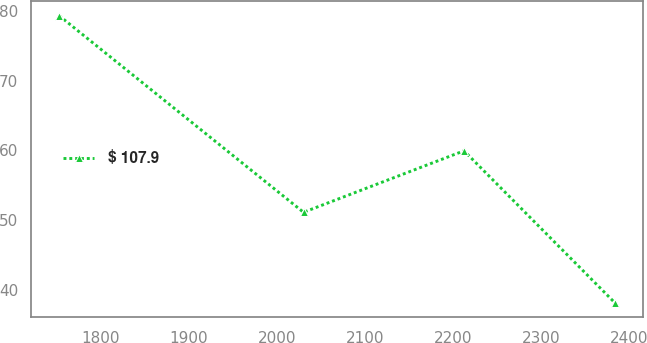<chart> <loc_0><loc_0><loc_500><loc_500><line_chart><ecel><fcel>$ 107.9<nl><fcel>1752.79<fcel>79.35<nl><fcel>2030.22<fcel>51.11<nl><fcel>2212.44<fcel>59.94<nl><fcel>2384.02<fcel>38.07<nl></chart> 